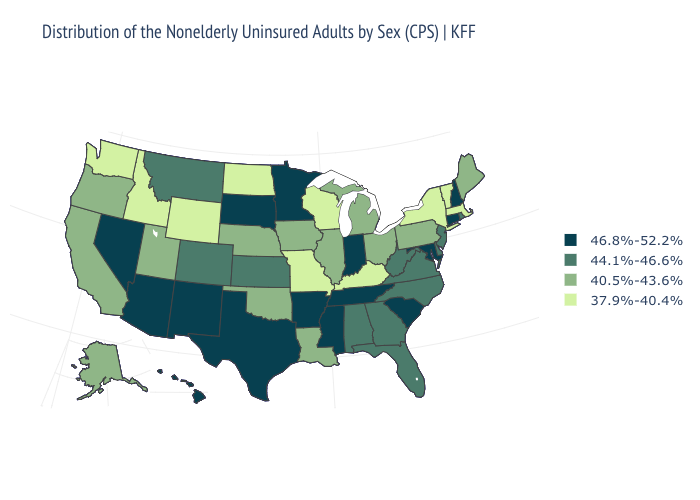Does South Dakota have the highest value in the MidWest?
Keep it brief. Yes. What is the highest value in the South ?
Answer briefly. 46.8%-52.2%. Does Michigan have the lowest value in the MidWest?
Short answer required. No. Name the states that have a value in the range 44.1%-46.6%?
Write a very short answer. Alabama, Colorado, Delaware, Florida, Georgia, Kansas, Montana, New Jersey, North Carolina, Rhode Island, Virginia, West Virginia. What is the value of Wisconsin?
Quick response, please. 37.9%-40.4%. What is the lowest value in the West?
Keep it brief. 37.9%-40.4%. What is the value of West Virginia?
Answer briefly. 44.1%-46.6%. Does the first symbol in the legend represent the smallest category?
Give a very brief answer. No. Among the states that border Rhode Island , does Connecticut have the highest value?
Quick response, please. Yes. Name the states that have a value in the range 46.8%-52.2%?
Write a very short answer. Arizona, Arkansas, Connecticut, Hawaii, Indiana, Maryland, Minnesota, Mississippi, Nevada, New Hampshire, New Mexico, South Carolina, South Dakota, Tennessee, Texas. Which states hav the highest value in the Northeast?
Concise answer only. Connecticut, New Hampshire. Name the states that have a value in the range 40.5%-43.6%?
Give a very brief answer. Alaska, California, Illinois, Iowa, Louisiana, Maine, Michigan, Nebraska, Ohio, Oklahoma, Oregon, Pennsylvania, Utah. Name the states that have a value in the range 44.1%-46.6%?
Write a very short answer. Alabama, Colorado, Delaware, Florida, Georgia, Kansas, Montana, New Jersey, North Carolina, Rhode Island, Virginia, West Virginia. Among the states that border California , does Oregon have the lowest value?
Keep it brief. Yes. What is the value of South Dakota?
Quick response, please. 46.8%-52.2%. 